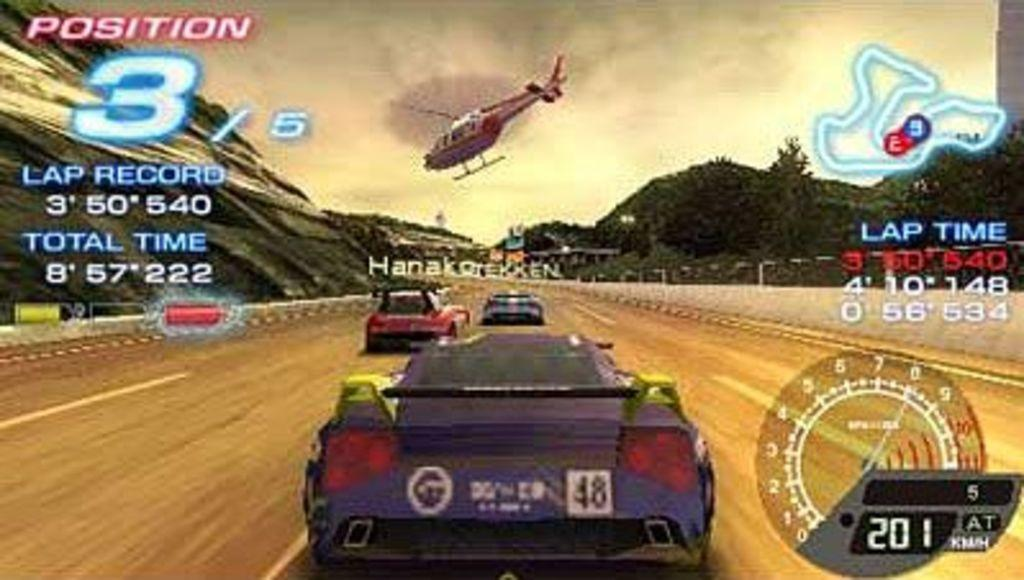What type of vehicles can be seen on the road in the image? There are cars on the road in the image. What other mode of transportation is present in the image? There is a helicopter in the image. What can be seen on the right side of the image? There are trees and a speedometer on the right side of the image. How does the face of the driver in the car look like in the image? There is no face visible in the image; only the cars, helicopter, trees, and speedometer can be seen. 